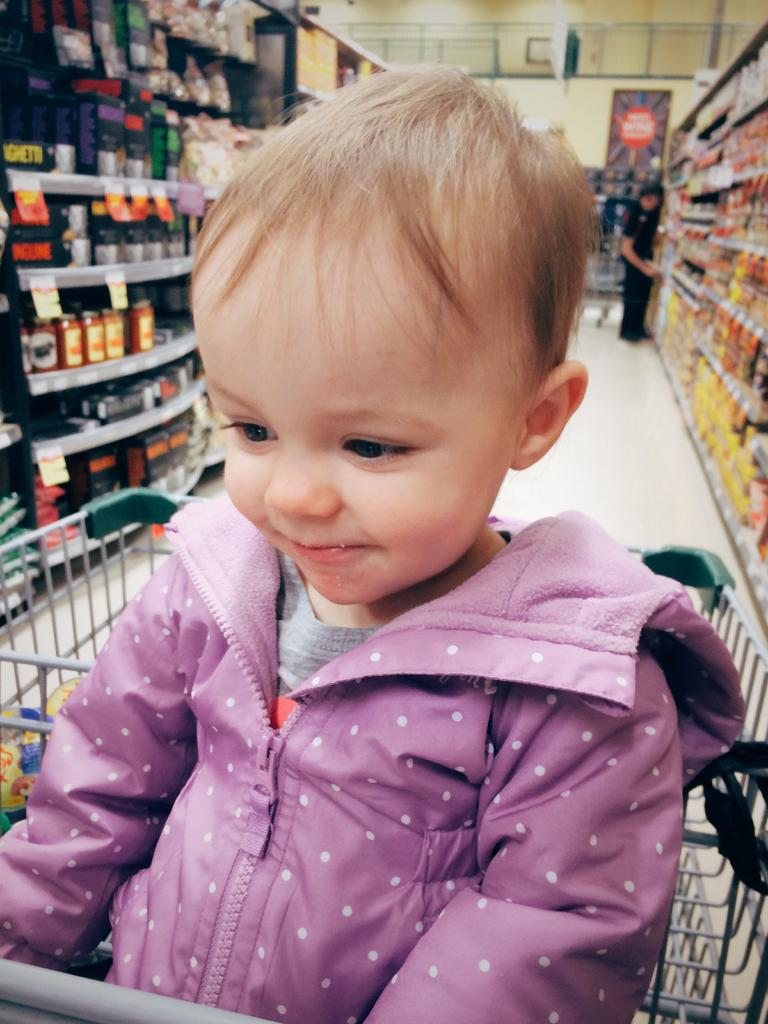What is the main subject of the image? There is a baby in the image. What can be seen in the background of the image? There are cracks filled with objects in the background. Is there anyone else present in the image besides the baby? Yes, a person is standing beside the rack in the background. Can you describe the sea visible in the image? There is no sea visible in the image; it features a baby and a background with cracks filled with objects. What type of ground is the baby standing on in the image? The facts provided do not mention the type of ground the baby is standing on, so we cannot determine that information from the image. 